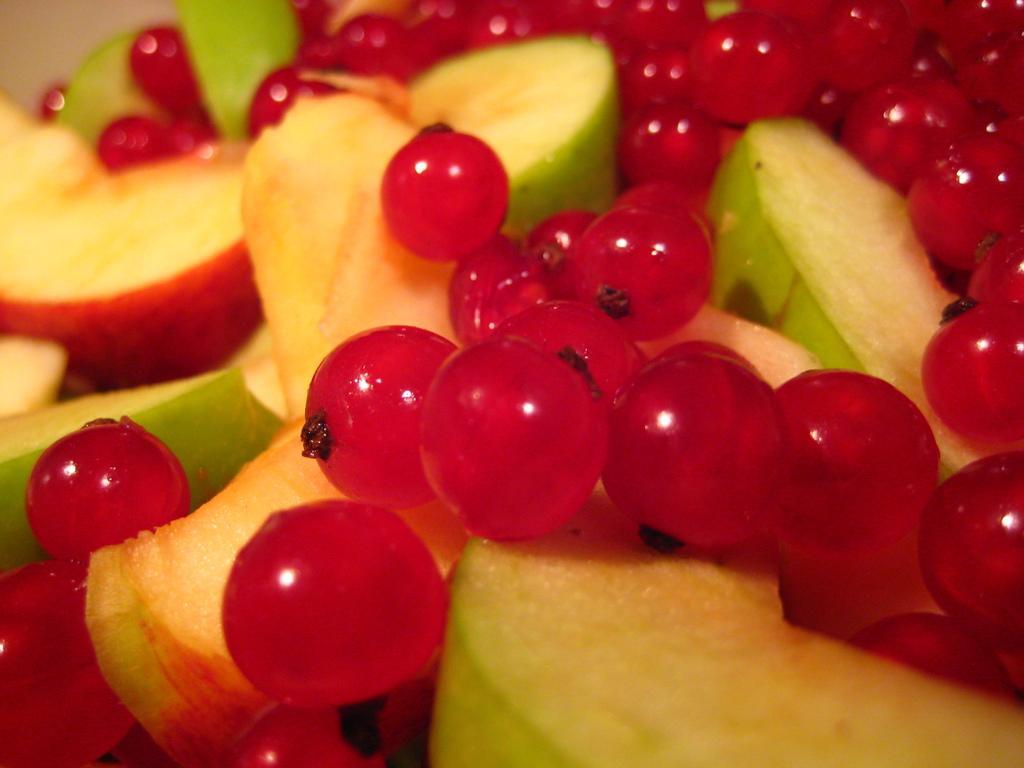Can you describe this image briefly? In this image we can see some fruits like apple and cherries. 